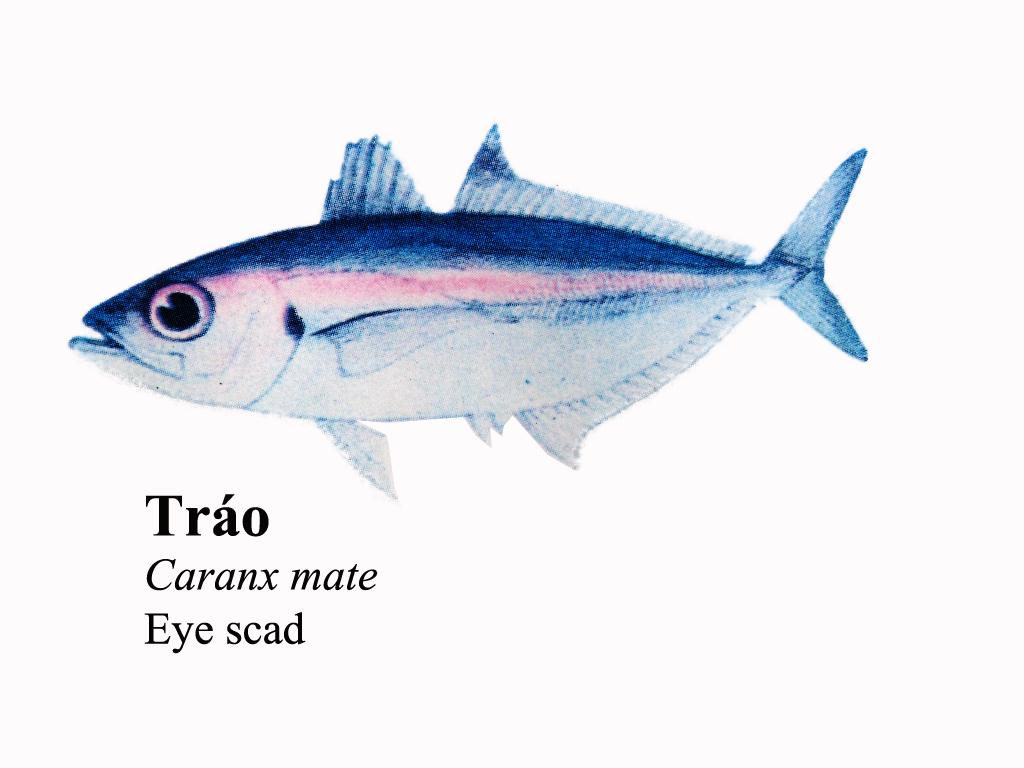What is the main subject of the image? There is a photo of a fish in the image. Are there any words or letters in the image? Yes, there is text in the image. What color is the background of the image? The background of the image is white. How many kittens can be seen playing on the edge of the prison in the image? There are no kittens or prison present in the image; it features a photo of a fish and text on a white background. 